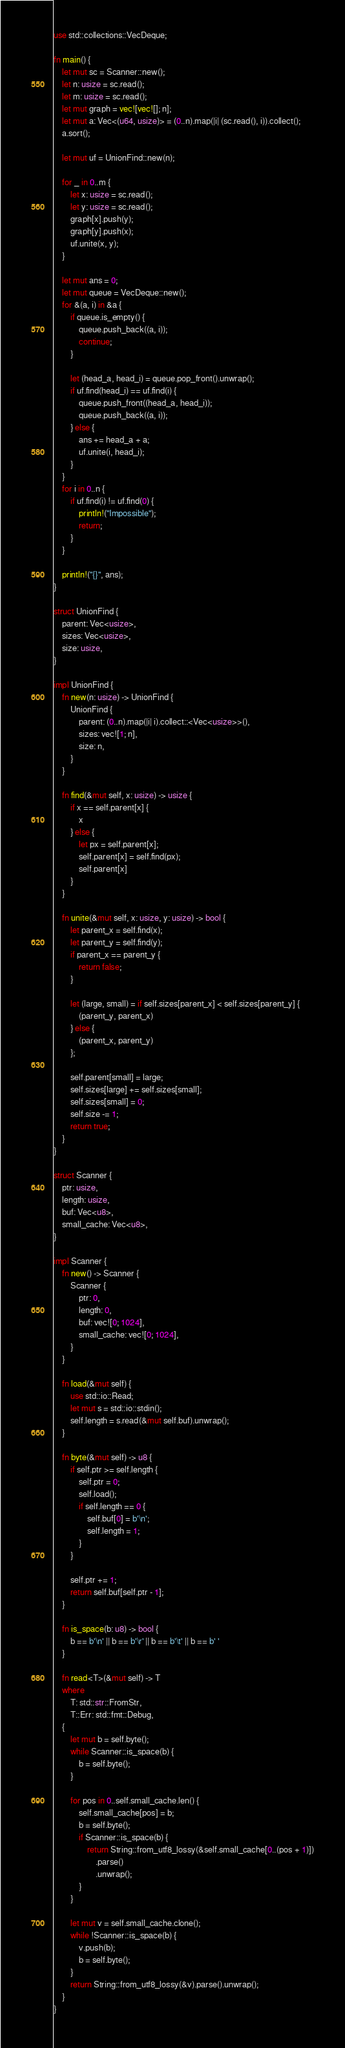Convert code to text. <code><loc_0><loc_0><loc_500><loc_500><_Rust_>use std::collections::VecDeque;

fn main() {
    let mut sc = Scanner::new();
    let n: usize = sc.read();
    let m: usize = sc.read();
    let mut graph = vec![vec![]; n];
    let mut a: Vec<(u64, usize)> = (0..n).map(|i| (sc.read(), i)).collect();
    a.sort();

    let mut uf = UnionFind::new(n);

    for _ in 0..m {
        let x: usize = sc.read();
        let y: usize = sc.read();
        graph[x].push(y);
        graph[y].push(x);
        uf.unite(x, y);
    }

    let mut ans = 0;
    let mut queue = VecDeque::new();
    for &(a, i) in &a {
        if queue.is_empty() {
            queue.push_back((a, i));
            continue;
        }

        let (head_a, head_i) = queue.pop_front().unwrap();
        if uf.find(head_i) == uf.find(i) {
            queue.push_front((head_a, head_i));
            queue.push_back((a, i));
        } else {
            ans += head_a + a;
            uf.unite(i, head_i);
        }
    }
    for i in 0..n {
        if uf.find(i) != uf.find(0) {
            println!("Impossible");
            return;
        }
    }

    println!("{}", ans);
}

struct UnionFind {
    parent: Vec<usize>,
    sizes: Vec<usize>,
    size: usize,
}

impl UnionFind {
    fn new(n: usize) -> UnionFind {
        UnionFind {
            parent: (0..n).map(|i| i).collect::<Vec<usize>>(),
            sizes: vec![1; n],
            size: n,
        }
    }

    fn find(&mut self, x: usize) -> usize {
        if x == self.parent[x] {
            x
        } else {
            let px = self.parent[x];
            self.parent[x] = self.find(px);
            self.parent[x]
        }
    }

    fn unite(&mut self, x: usize, y: usize) -> bool {
        let parent_x = self.find(x);
        let parent_y = self.find(y);
        if parent_x == parent_y {
            return false;
        }

        let (large, small) = if self.sizes[parent_x] < self.sizes[parent_y] {
            (parent_y, parent_x)
        } else {
            (parent_x, parent_y)
        };

        self.parent[small] = large;
        self.sizes[large] += self.sizes[small];
        self.sizes[small] = 0;
        self.size -= 1;
        return true;
    }
}

struct Scanner {
    ptr: usize,
    length: usize,
    buf: Vec<u8>,
    small_cache: Vec<u8>,
}

impl Scanner {
    fn new() -> Scanner {
        Scanner {
            ptr: 0,
            length: 0,
            buf: vec![0; 1024],
            small_cache: vec![0; 1024],
        }
    }

    fn load(&mut self) {
        use std::io::Read;
        let mut s = std::io::stdin();
        self.length = s.read(&mut self.buf).unwrap();
    }

    fn byte(&mut self) -> u8 {
        if self.ptr >= self.length {
            self.ptr = 0;
            self.load();
            if self.length == 0 {
                self.buf[0] = b'\n';
                self.length = 1;
            }
        }

        self.ptr += 1;
        return self.buf[self.ptr - 1];
    }

    fn is_space(b: u8) -> bool {
        b == b'\n' || b == b'\r' || b == b'\t' || b == b' '
    }

    fn read<T>(&mut self) -> T
    where
        T: std::str::FromStr,
        T::Err: std::fmt::Debug,
    {
        let mut b = self.byte();
        while Scanner::is_space(b) {
            b = self.byte();
        }

        for pos in 0..self.small_cache.len() {
            self.small_cache[pos] = b;
            b = self.byte();
            if Scanner::is_space(b) {
                return String::from_utf8_lossy(&self.small_cache[0..(pos + 1)])
                    .parse()
                    .unwrap();
            }
        }

        let mut v = self.small_cache.clone();
        while !Scanner::is_space(b) {
            v.push(b);
            b = self.byte();
        }
        return String::from_utf8_lossy(&v).parse().unwrap();
    }
}
</code> 